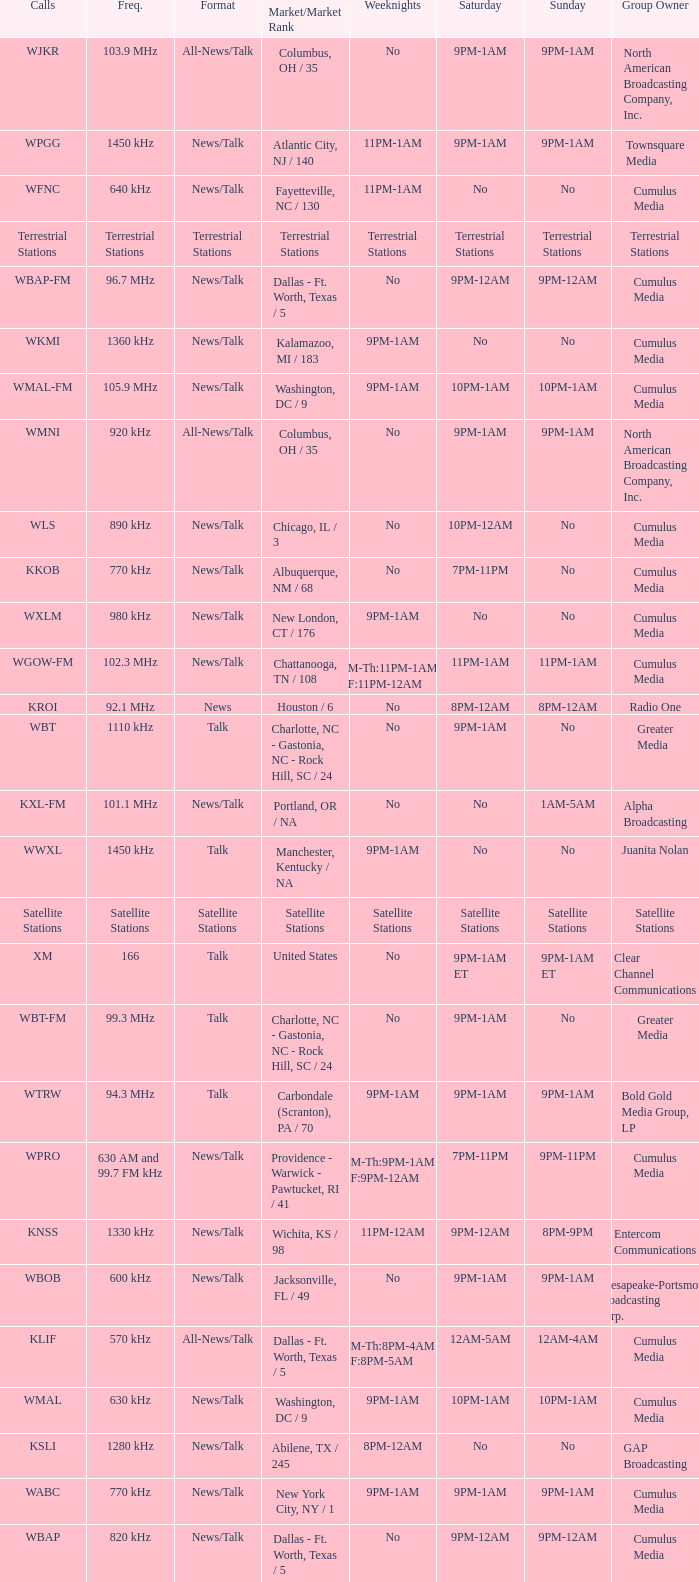What is the market for the 11pm-1am Saturday game? Chattanooga, TN / 108. 